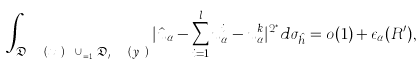<formula> <loc_0><loc_0><loc_500><loc_500>\int _ { \mathfrak { D } _ { R \mu ^ { k } _ { \alpha } } ( x ^ { k } _ { \alpha } ) \ \cup ^ { s } _ { j = 1 } \mathfrak { D } _ { R ^ { \prime } \lambda ^ { j } _ { \alpha } } ( y ^ { j } _ { \alpha } ) } | \hat { u } _ { \alpha } - \sum ^ { l } _ { i = 1 } u ^ { i } _ { \alpha } - u ^ { k } _ { \alpha } | ^ { 2 ^ { * } } d \sigma _ { \hat { h } } = o ( 1 ) + \epsilon _ { \alpha } ( R ^ { \prime } ) ,</formula> 